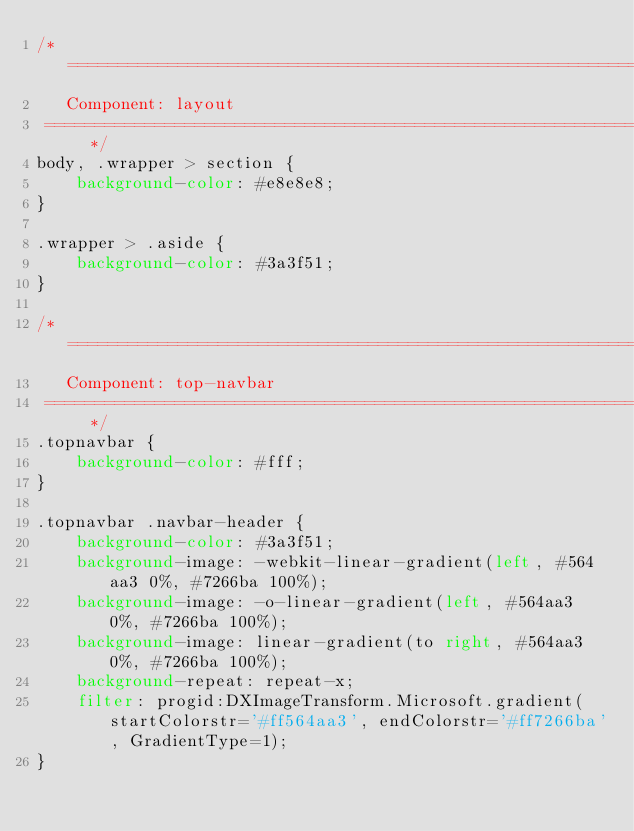Convert code to text. <code><loc_0><loc_0><loc_500><loc_500><_CSS_>/* ========================================================================
   Component: layout
 ========================================================================== */
body, .wrapper > section {
    background-color: #e8e8e8;
}

.wrapper > .aside {
    background-color: #3a3f51;
}

/* ========================================================================
   Component: top-navbar
 ========================================================================== */
.topnavbar {
    background-color: #fff;
}

.topnavbar .navbar-header {
    background-color: #3a3f51;
    background-image: -webkit-linear-gradient(left, #564aa3 0%, #7266ba 100%);
    background-image: -o-linear-gradient(left, #564aa3 0%, #7266ba 100%);
    background-image: linear-gradient(to right, #564aa3 0%, #7266ba 100%);
    background-repeat: repeat-x;
    filter: progid:DXImageTransform.Microsoft.gradient(startColorstr='#ff564aa3', endColorstr='#ff7266ba', GradientType=1);
}
</code> 